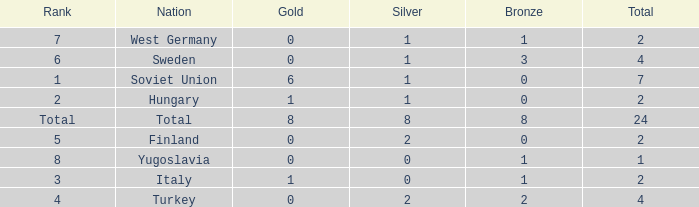When the total is 7 and silver exceeds 1, what is the typical bronze value? None. 